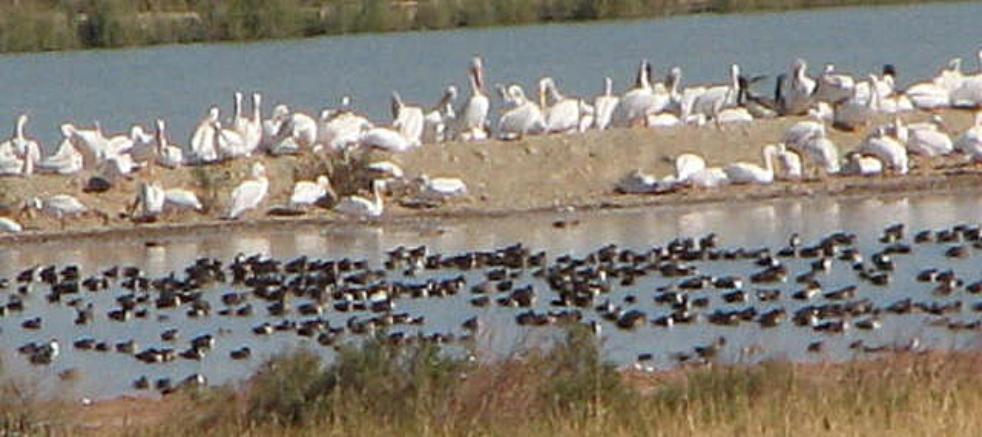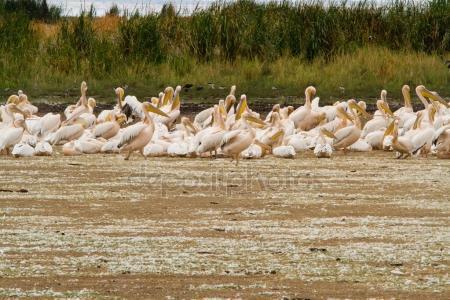The first image is the image on the left, the second image is the image on the right. Analyze the images presented: Is the assertion "The image on the right contains an animal that is not a bird." valid? Answer yes or no. No. The first image is the image on the left, the second image is the image on the right. Analyze the images presented: Is the assertion "There is at least one picture where water is not visible." valid? Answer yes or no. Yes. 